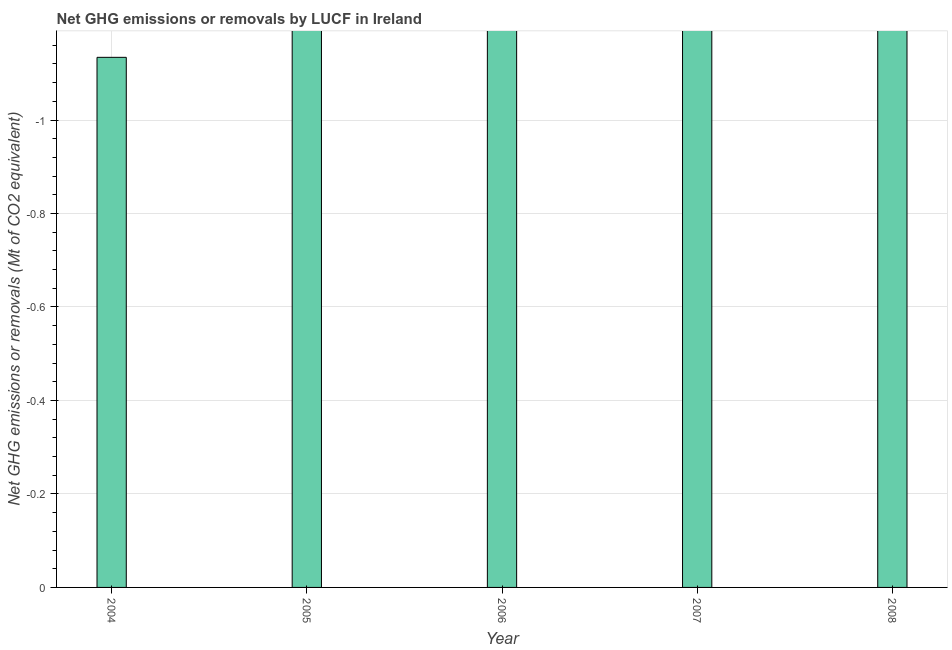Does the graph contain any zero values?
Your response must be concise. Yes. Does the graph contain grids?
Your response must be concise. Yes. What is the title of the graph?
Offer a terse response. Net GHG emissions or removals by LUCF in Ireland. What is the label or title of the Y-axis?
Ensure brevity in your answer.  Net GHG emissions or removals (Mt of CO2 equivalent). What is the ghg net emissions or removals in 2007?
Your answer should be very brief. 0. Across all years, what is the minimum ghg net emissions or removals?
Provide a succinct answer. 0. What is the sum of the ghg net emissions or removals?
Make the answer very short. 0. What is the median ghg net emissions or removals?
Give a very brief answer. 0. In how many years, is the ghg net emissions or removals greater than -0.16 Mt?
Provide a short and direct response. 0. In how many years, is the ghg net emissions or removals greater than the average ghg net emissions or removals taken over all years?
Your response must be concise. 0. How many bars are there?
Your answer should be compact. 0. Are all the bars in the graph horizontal?
Give a very brief answer. No. What is the difference between two consecutive major ticks on the Y-axis?
Offer a terse response. 0.2. What is the Net GHG emissions or removals (Mt of CO2 equivalent) of 2004?
Give a very brief answer. 0. What is the Net GHG emissions or removals (Mt of CO2 equivalent) in 2006?
Provide a short and direct response. 0. What is the Net GHG emissions or removals (Mt of CO2 equivalent) of 2007?
Your response must be concise. 0. 